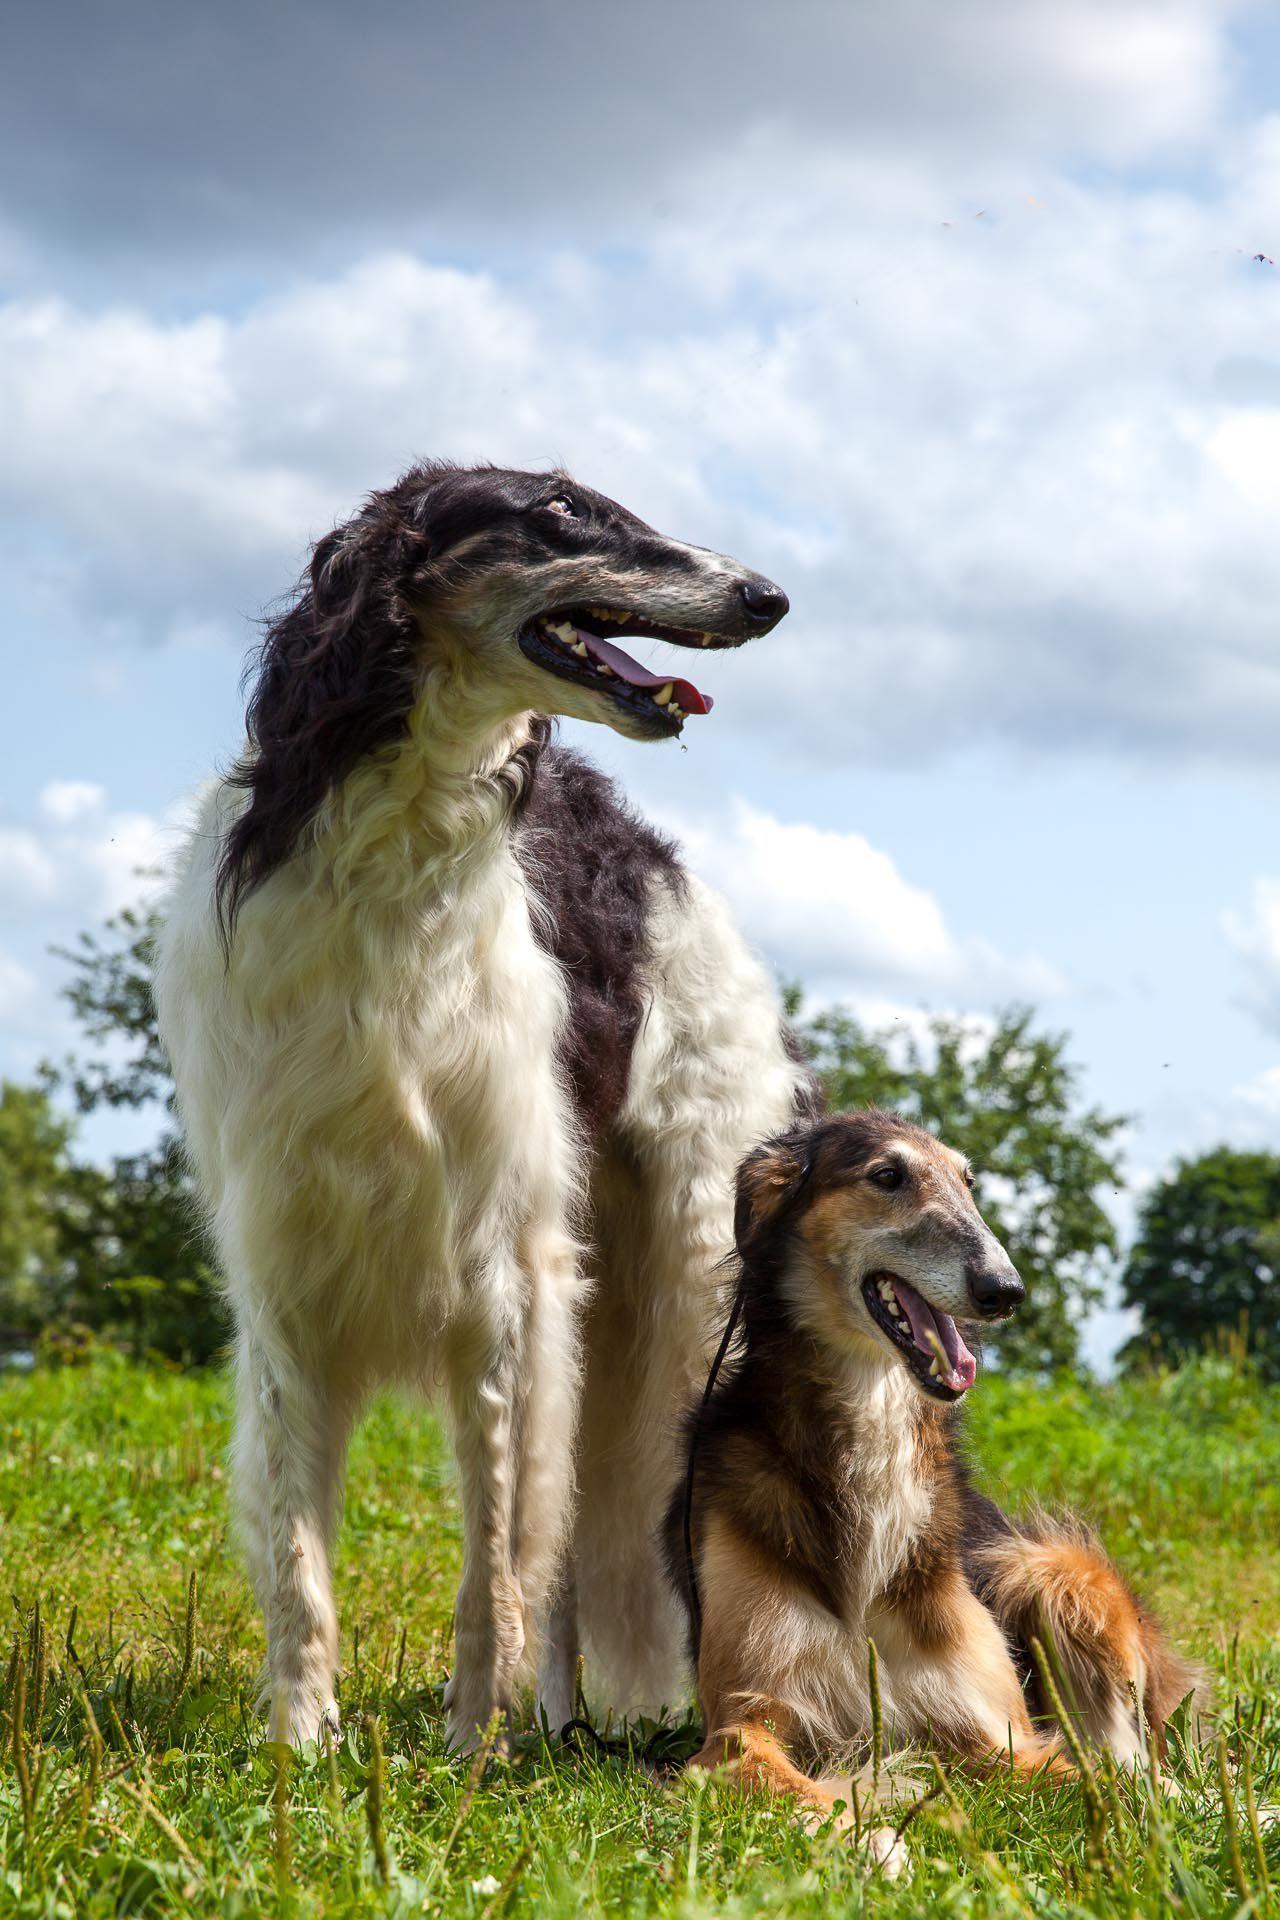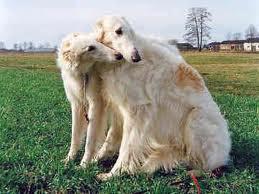The first image is the image on the left, the second image is the image on the right. Considering the images on both sides, is "There is at least 1 black and white dog that is not facing right." valid? Answer yes or no. No. The first image is the image on the left, the second image is the image on the right. For the images displayed, is the sentence "A long-haired dog with a thin face is standing with no other dogs." factually correct? Answer yes or no. No. 